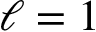Convert formula to latex. <formula><loc_0><loc_0><loc_500><loc_500>\ell = 1</formula> 